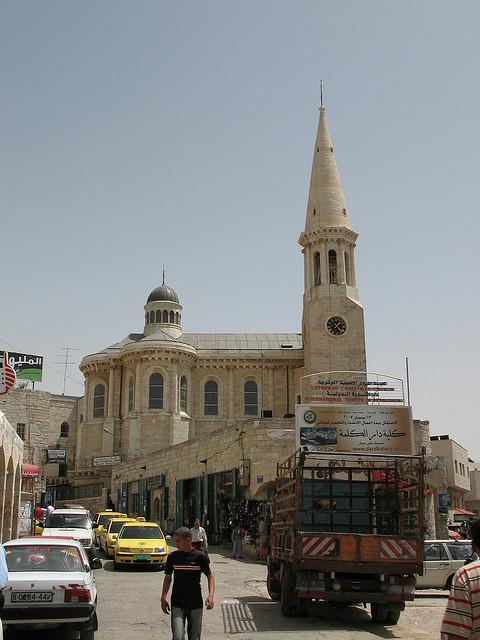How many yellow vehicles are in this photo?
Give a very brief answer. 3. How many cars are in this photo?
Give a very brief answer. 6. How many cars are there?
Give a very brief answer. 2. How many people can be seen?
Give a very brief answer. 2. How many motorcycles have an american flag on them?
Give a very brief answer. 0. 